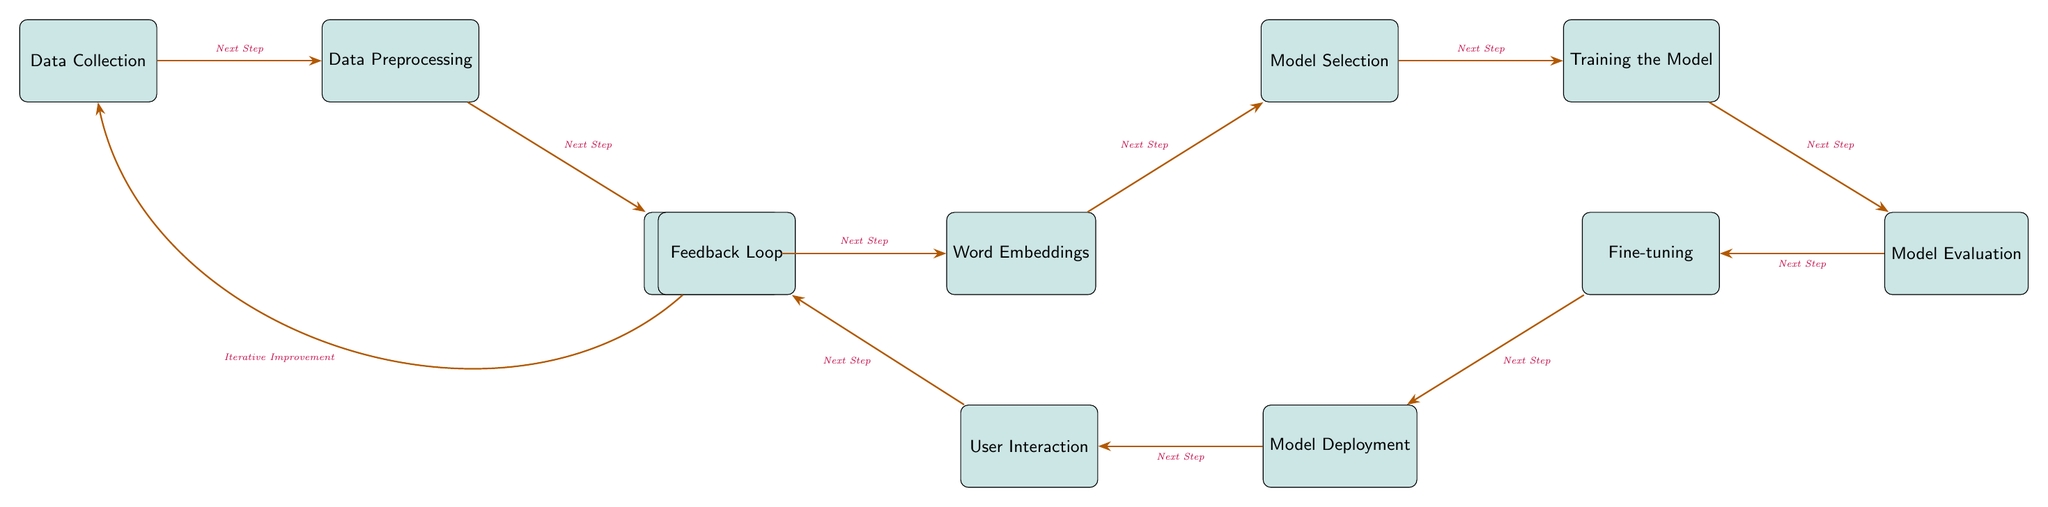What is the first step in the diagram? The first step shown in the diagram is "Data Collection". It is the leftmost node and has an arrow pointing to the next step, indicating the flow starts here.
Answer: Data Collection How many total nodes are present in the diagram? By counting each individual box, we find there are 10 nodes in total, each representing a different process or aspect of predictive text generation.
Answer: 10 What does the "User Interaction" node connect to? The "User Interaction" node connects directly to the "Feedback Loop" node, which allows for ongoing improvement based on user input and interaction.
Answer: Feedback Loop Which node precedes "Model Evaluation"? The "Training the Model" node directly precedes "Model Evaluation". The arrow shows the progression from training towards evaluating the model's performance.
Answer: Training the Model What type of interaction occurs in the "Feedback Loop"? The "Feedback Loop" indicates "Iterative Improvement" as its purpose, which suggests a continuous cycle of gathering feedback to enhance the data collection process.
Answer: Iterative Improvement Which nodes form part of the model implementation phase? The model implementation phase includes the nodes "Training the Model," "Model Evaluation," "Fine-tuning," and "Deployment." These nodes are directly related to modeling and applying the machine learning framework.
Answer: Training the Model, Model Evaluation, Fine-tuning, Deployment How does "Data Preprocessing" relate to "Tokenization"? "Data Preprocessing" leads directly to "Tokenization" with a flow arrow, indicating that tokenization is the next step in the data processing pipeline.
Answer: Next Step What is the main theme of the diagram? The main theme of the diagram is "Predictive Text Generation to Assist in Creative Writing Exercises," encapsulating the entire process from data collection to user interaction and feedback.
Answer: Predictive Text Generation 